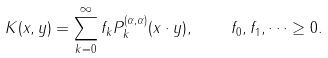<formula> <loc_0><loc_0><loc_500><loc_500>K ( x , y ) = \sum _ { k = 0 } ^ { \infty } f _ { k } P ^ { ( \alpha , \alpha ) } _ { k } ( x \cdot y ) , \quad f _ { 0 } , f _ { 1 } , \dots \geq 0 .</formula> 